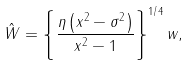Convert formula to latex. <formula><loc_0><loc_0><loc_500><loc_500>\hat { W } = \left \{ { \frac { \eta \left ( { x ^ { 2 } - \sigma ^ { 2 } } \right ) } { x ^ { 2 } - 1 } } \right \} ^ { 1 / 4 } w ,</formula> 